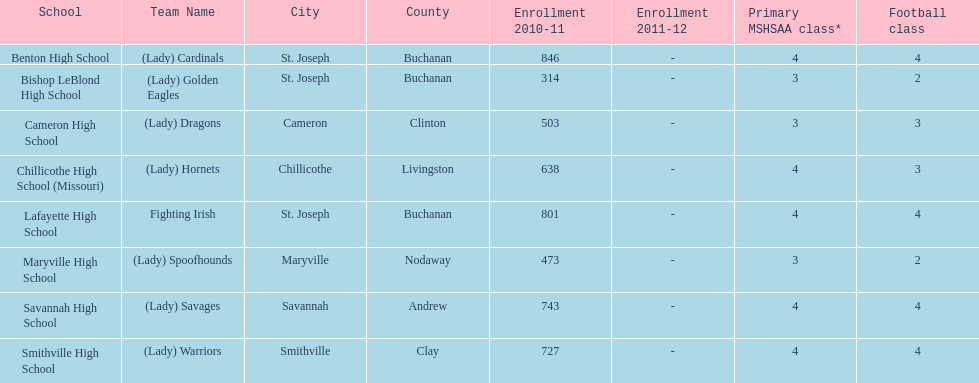Which school has the largest enrollment? Benton High School. 